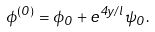Convert formula to latex. <formula><loc_0><loc_0><loc_500><loc_500>\phi ^ { ( 0 ) } = \phi _ { 0 } + e ^ { 4 y / l } \psi _ { 0 } .</formula> 